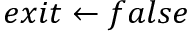Convert formula to latex. <formula><loc_0><loc_0><loc_500><loc_500>e x i t \gets f a l s e</formula> 